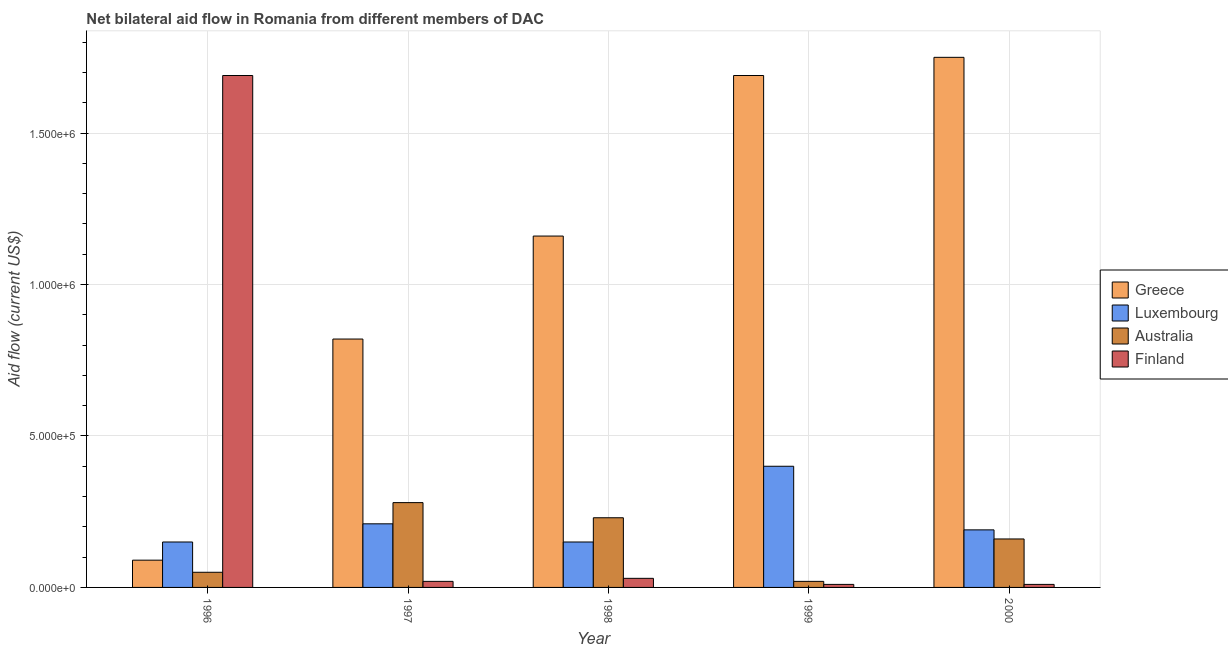How many groups of bars are there?
Give a very brief answer. 5. Are the number of bars per tick equal to the number of legend labels?
Your answer should be compact. Yes. Are the number of bars on each tick of the X-axis equal?
Give a very brief answer. Yes. How many bars are there on the 3rd tick from the left?
Offer a very short reply. 4. What is the amount of aid given by finland in 1997?
Give a very brief answer. 2.00e+04. Across all years, what is the maximum amount of aid given by luxembourg?
Make the answer very short. 4.00e+05. Across all years, what is the minimum amount of aid given by greece?
Keep it short and to the point. 9.00e+04. In which year was the amount of aid given by luxembourg maximum?
Your response must be concise. 1999. What is the total amount of aid given by greece in the graph?
Provide a short and direct response. 5.51e+06. What is the difference between the amount of aid given by luxembourg in 1997 and the amount of aid given by australia in 1996?
Offer a terse response. 6.00e+04. What is the average amount of aid given by australia per year?
Your response must be concise. 1.48e+05. Is the difference between the amount of aid given by australia in 1997 and 2000 greater than the difference between the amount of aid given by greece in 1997 and 2000?
Your answer should be very brief. No. What is the difference between the highest and the second highest amount of aid given by australia?
Your answer should be very brief. 5.00e+04. What is the difference between the highest and the lowest amount of aid given by luxembourg?
Your answer should be compact. 2.50e+05. In how many years, is the amount of aid given by finland greater than the average amount of aid given by finland taken over all years?
Offer a terse response. 1. Is the sum of the amount of aid given by luxembourg in 1998 and 1999 greater than the maximum amount of aid given by australia across all years?
Make the answer very short. Yes. What does the 2nd bar from the left in 1998 represents?
Make the answer very short. Luxembourg. What does the 1st bar from the right in 1999 represents?
Offer a very short reply. Finland. How many bars are there?
Provide a short and direct response. 20. Does the graph contain any zero values?
Offer a terse response. No. Where does the legend appear in the graph?
Give a very brief answer. Center right. How many legend labels are there?
Your answer should be compact. 4. What is the title of the graph?
Keep it short and to the point. Net bilateral aid flow in Romania from different members of DAC. Does "Insurance services" appear as one of the legend labels in the graph?
Provide a short and direct response. No. What is the label or title of the X-axis?
Your answer should be compact. Year. What is the Aid flow (current US$) of Greece in 1996?
Keep it short and to the point. 9.00e+04. What is the Aid flow (current US$) in Luxembourg in 1996?
Your response must be concise. 1.50e+05. What is the Aid flow (current US$) of Australia in 1996?
Ensure brevity in your answer.  5.00e+04. What is the Aid flow (current US$) of Finland in 1996?
Make the answer very short. 1.69e+06. What is the Aid flow (current US$) of Greece in 1997?
Ensure brevity in your answer.  8.20e+05. What is the Aid flow (current US$) of Luxembourg in 1997?
Your answer should be compact. 2.10e+05. What is the Aid flow (current US$) of Greece in 1998?
Offer a terse response. 1.16e+06. What is the Aid flow (current US$) in Luxembourg in 1998?
Offer a very short reply. 1.50e+05. What is the Aid flow (current US$) of Australia in 1998?
Provide a succinct answer. 2.30e+05. What is the Aid flow (current US$) in Greece in 1999?
Make the answer very short. 1.69e+06. What is the Aid flow (current US$) in Luxembourg in 1999?
Make the answer very short. 4.00e+05. What is the Aid flow (current US$) in Australia in 1999?
Keep it short and to the point. 2.00e+04. What is the Aid flow (current US$) in Greece in 2000?
Keep it short and to the point. 1.75e+06. What is the Aid flow (current US$) of Finland in 2000?
Your response must be concise. 10000. Across all years, what is the maximum Aid flow (current US$) of Greece?
Keep it short and to the point. 1.75e+06. Across all years, what is the maximum Aid flow (current US$) of Luxembourg?
Ensure brevity in your answer.  4.00e+05. Across all years, what is the maximum Aid flow (current US$) in Australia?
Make the answer very short. 2.80e+05. Across all years, what is the maximum Aid flow (current US$) in Finland?
Keep it short and to the point. 1.69e+06. Across all years, what is the minimum Aid flow (current US$) in Luxembourg?
Your answer should be compact. 1.50e+05. What is the total Aid flow (current US$) of Greece in the graph?
Provide a short and direct response. 5.51e+06. What is the total Aid flow (current US$) of Luxembourg in the graph?
Keep it short and to the point. 1.10e+06. What is the total Aid flow (current US$) of Australia in the graph?
Ensure brevity in your answer.  7.40e+05. What is the total Aid flow (current US$) of Finland in the graph?
Keep it short and to the point. 1.76e+06. What is the difference between the Aid flow (current US$) of Greece in 1996 and that in 1997?
Offer a terse response. -7.30e+05. What is the difference between the Aid flow (current US$) in Finland in 1996 and that in 1997?
Keep it short and to the point. 1.67e+06. What is the difference between the Aid flow (current US$) in Greece in 1996 and that in 1998?
Make the answer very short. -1.07e+06. What is the difference between the Aid flow (current US$) in Luxembourg in 1996 and that in 1998?
Your answer should be compact. 0. What is the difference between the Aid flow (current US$) in Australia in 1996 and that in 1998?
Provide a succinct answer. -1.80e+05. What is the difference between the Aid flow (current US$) of Finland in 1996 and that in 1998?
Offer a terse response. 1.66e+06. What is the difference between the Aid flow (current US$) of Greece in 1996 and that in 1999?
Make the answer very short. -1.60e+06. What is the difference between the Aid flow (current US$) of Australia in 1996 and that in 1999?
Provide a succinct answer. 3.00e+04. What is the difference between the Aid flow (current US$) of Finland in 1996 and that in 1999?
Provide a short and direct response. 1.68e+06. What is the difference between the Aid flow (current US$) in Greece in 1996 and that in 2000?
Offer a terse response. -1.66e+06. What is the difference between the Aid flow (current US$) in Luxembourg in 1996 and that in 2000?
Keep it short and to the point. -4.00e+04. What is the difference between the Aid flow (current US$) in Finland in 1996 and that in 2000?
Make the answer very short. 1.68e+06. What is the difference between the Aid flow (current US$) in Australia in 1997 and that in 1998?
Your response must be concise. 5.00e+04. What is the difference between the Aid flow (current US$) of Greece in 1997 and that in 1999?
Keep it short and to the point. -8.70e+05. What is the difference between the Aid flow (current US$) of Australia in 1997 and that in 1999?
Provide a short and direct response. 2.60e+05. What is the difference between the Aid flow (current US$) in Greece in 1997 and that in 2000?
Your answer should be compact. -9.30e+05. What is the difference between the Aid flow (current US$) of Luxembourg in 1997 and that in 2000?
Provide a short and direct response. 2.00e+04. What is the difference between the Aid flow (current US$) of Finland in 1997 and that in 2000?
Provide a succinct answer. 10000. What is the difference between the Aid flow (current US$) in Greece in 1998 and that in 1999?
Offer a terse response. -5.30e+05. What is the difference between the Aid flow (current US$) in Greece in 1998 and that in 2000?
Offer a terse response. -5.90e+05. What is the difference between the Aid flow (current US$) of Australia in 1998 and that in 2000?
Offer a terse response. 7.00e+04. What is the difference between the Aid flow (current US$) in Finland in 1998 and that in 2000?
Your answer should be very brief. 2.00e+04. What is the difference between the Aid flow (current US$) of Greece in 1999 and that in 2000?
Offer a terse response. -6.00e+04. What is the difference between the Aid flow (current US$) of Australia in 1996 and the Aid flow (current US$) of Finland in 1997?
Make the answer very short. 3.00e+04. What is the difference between the Aid flow (current US$) in Greece in 1996 and the Aid flow (current US$) in Australia in 1998?
Your answer should be very brief. -1.40e+05. What is the difference between the Aid flow (current US$) of Greece in 1996 and the Aid flow (current US$) of Finland in 1998?
Ensure brevity in your answer.  6.00e+04. What is the difference between the Aid flow (current US$) of Luxembourg in 1996 and the Aid flow (current US$) of Australia in 1998?
Offer a very short reply. -8.00e+04. What is the difference between the Aid flow (current US$) of Greece in 1996 and the Aid flow (current US$) of Luxembourg in 1999?
Ensure brevity in your answer.  -3.10e+05. What is the difference between the Aid flow (current US$) in Greece in 1996 and the Aid flow (current US$) in Australia in 1999?
Your answer should be very brief. 7.00e+04. What is the difference between the Aid flow (current US$) of Greece in 1996 and the Aid flow (current US$) of Finland in 1999?
Your answer should be compact. 8.00e+04. What is the difference between the Aid flow (current US$) of Australia in 1996 and the Aid flow (current US$) of Finland in 1999?
Provide a succinct answer. 4.00e+04. What is the difference between the Aid flow (current US$) in Greece in 1996 and the Aid flow (current US$) in Australia in 2000?
Provide a short and direct response. -7.00e+04. What is the difference between the Aid flow (current US$) in Greece in 1997 and the Aid flow (current US$) in Luxembourg in 1998?
Make the answer very short. 6.70e+05. What is the difference between the Aid flow (current US$) in Greece in 1997 and the Aid flow (current US$) in Australia in 1998?
Your answer should be very brief. 5.90e+05. What is the difference between the Aid flow (current US$) in Greece in 1997 and the Aid flow (current US$) in Finland in 1998?
Keep it short and to the point. 7.90e+05. What is the difference between the Aid flow (current US$) in Luxembourg in 1997 and the Aid flow (current US$) in Finland in 1998?
Make the answer very short. 1.80e+05. What is the difference between the Aid flow (current US$) in Australia in 1997 and the Aid flow (current US$) in Finland in 1998?
Keep it short and to the point. 2.50e+05. What is the difference between the Aid flow (current US$) in Greece in 1997 and the Aid flow (current US$) in Luxembourg in 1999?
Offer a terse response. 4.20e+05. What is the difference between the Aid flow (current US$) of Greece in 1997 and the Aid flow (current US$) of Australia in 1999?
Ensure brevity in your answer.  8.00e+05. What is the difference between the Aid flow (current US$) of Greece in 1997 and the Aid flow (current US$) of Finland in 1999?
Offer a terse response. 8.10e+05. What is the difference between the Aid flow (current US$) of Luxembourg in 1997 and the Aid flow (current US$) of Australia in 1999?
Your answer should be compact. 1.90e+05. What is the difference between the Aid flow (current US$) of Luxembourg in 1997 and the Aid flow (current US$) of Finland in 1999?
Your answer should be compact. 2.00e+05. What is the difference between the Aid flow (current US$) in Australia in 1997 and the Aid flow (current US$) in Finland in 1999?
Ensure brevity in your answer.  2.70e+05. What is the difference between the Aid flow (current US$) in Greece in 1997 and the Aid flow (current US$) in Luxembourg in 2000?
Your response must be concise. 6.30e+05. What is the difference between the Aid flow (current US$) of Greece in 1997 and the Aid flow (current US$) of Australia in 2000?
Make the answer very short. 6.60e+05. What is the difference between the Aid flow (current US$) of Greece in 1997 and the Aid flow (current US$) of Finland in 2000?
Keep it short and to the point. 8.10e+05. What is the difference between the Aid flow (current US$) in Luxembourg in 1997 and the Aid flow (current US$) in Australia in 2000?
Your answer should be compact. 5.00e+04. What is the difference between the Aid flow (current US$) in Australia in 1997 and the Aid flow (current US$) in Finland in 2000?
Offer a terse response. 2.70e+05. What is the difference between the Aid flow (current US$) in Greece in 1998 and the Aid flow (current US$) in Luxembourg in 1999?
Offer a very short reply. 7.60e+05. What is the difference between the Aid flow (current US$) in Greece in 1998 and the Aid flow (current US$) in Australia in 1999?
Ensure brevity in your answer.  1.14e+06. What is the difference between the Aid flow (current US$) in Greece in 1998 and the Aid flow (current US$) in Finland in 1999?
Ensure brevity in your answer.  1.15e+06. What is the difference between the Aid flow (current US$) in Luxembourg in 1998 and the Aid flow (current US$) in Australia in 1999?
Offer a very short reply. 1.30e+05. What is the difference between the Aid flow (current US$) in Greece in 1998 and the Aid flow (current US$) in Luxembourg in 2000?
Offer a very short reply. 9.70e+05. What is the difference between the Aid flow (current US$) in Greece in 1998 and the Aid flow (current US$) in Australia in 2000?
Offer a terse response. 1.00e+06. What is the difference between the Aid flow (current US$) of Greece in 1998 and the Aid flow (current US$) of Finland in 2000?
Provide a succinct answer. 1.15e+06. What is the difference between the Aid flow (current US$) in Luxembourg in 1998 and the Aid flow (current US$) in Australia in 2000?
Give a very brief answer. -10000. What is the difference between the Aid flow (current US$) of Australia in 1998 and the Aid flow (current US$) of Finland in 2000?
Give a very brief answer. 2.20e+05. What is the difference between the Aid flow (current US$) of Greece in 1999 and the Aid flow (current US$) of Luxembourg in 2000?
Ensure brevity in your answer.  1.50e+06. What is the difference between the Aid flow (current US$) of Greece in 1999 and the Aid flow (current US$) of Australia in 2000?
Provide a short and direct response. 1.53e+06. What is the difference between the Aid flow (current US$) in Greece in 1999 and the Aid flow (current US$) in Finland in 2000?
Your answer should be very brief. 1.68e+06. What is the average Aid flow (current US$) of Greece per year?
Offer a terse response. 1.10e+06. What is the average Aid flow (current US$) in Luxembourg per year?
Keep it short and to the point. 2.20e+05. What is the average Aid flow (current US$) in Australia per year?
Ensure brevity in your answer.  1.48e+05. What is the average Aid flow (current US$) of Finland per year?
Give a very brief answer. 3.52e+05. In the year 1996, what is the difference between the Aid flow (current US$) in Greece and Aid flow (current US$) in Luxembourg?
Make the answer very short. -6.00e+04. In the year 1996, what is the difference between the Aid flow (current US$) in Greece and Aid flow (current US$) in Finland?
Provide a succinct answer. -1.60e+06. In the year 1996, what is the difference between the Aid flow (current US$) in Luxembourg and Aid flow (current US$) in Finland?
Ensure brevity in your answer.  -1.54e+06. In the year 1996, what is the difference between the Aid flow (current US$) in Australia and Aid flow (current US$) in Finland?
Ensure brevity in your answer.  -1.64e+06. In the year 1997, what is the difference between the Aid flow (current US$) in Greece and Aid flow (current US$) in Australia?
Offer a very short reply. 5.40e+05. In the year 1997, what is the difference between the Aid flow (current US$) in Luxembourg and Aid flow (current US$) in Finland?
Offer a terse response. 1.90e+05. In the year 1998, what is the difference between the Aid flow (current US$) of Greece and Aid flow (current US$) of Luxembourg?
Your answer should be very brief. 1.01e+06. In the year 1998, what is the difference between the Aid flow (current US$) in Greece and Aid flow (current US$) in Australia?
Your answer should be very brief. 9.30e+05. In the year 1998, what is the difference between the Aid flow (current US$) in Greece and Aid flow (current US$) in Finland?
Give a very brief answer. 1.13e+06. In the year 1998, what is the difference between the Aid flow (current US$) in Luxembourg and Aid flow (current US$) in Australia?
Ensure brevity in your answer.  -8.00e+04. In the year 1998, what is the difference between the Aid flow (current US$) in Luxembourg and Aid flow (current US$) in Finland?
Make the answer very short. 1.20e+05. In the year 1998, what is the difference between the Aid flow (current US$) of Australia and Aid flow (current US$) of Finland?
Offer a terse response. 2.00e+05. In the year 1999, what is the difference between the Aid flow (current US$) in Greece and Aid flow (current US$) in Luxembourg?
Keep it short and to the point. 1.29e+06. In the year 1999, what is the difference between the Aid flow (current US$) of Greece and Aid flow (current US$) of Australia?
Provide a succinct answer. 1.67e+06. In the year 1999, what is the difference between the Aid flow (current US$) of Greece and Aid flow (current US$) of Finland?
Offer a very short reply. 1.68e+06. In the year 1999, what is the difference between the Aid flow (current US$) of Luxembourg and Aid flow (current US$) of Australia?
Ensure brevity in your answer.  3.80e+05. In the year 1999, what is the difference between the Aid flow (current US$) in Australia and Aid flow (current US$) in Finland?
Offer a terse response. 10000. In the year 2000, what is the difference between the Aid flow (current US$) in Greece and Aid flow (current US$) in Luxembourg?
Your response must be concise. 1.56e+06. In the year 2000, what is the difference between the Aid flow (current US$) in Greece and Aid flow (current US$) in Australia?
Give a very brief answer. 1.59e+06. In the year 2000, what is the difference between the Aid flow (current US$) of Greece and Aid flow (current US$) of Finland?
Offer a very short reply. 1.74e+06. What is the ratio of the Aid flow (current US$) in Greece in 1996 to that in 1997?
Give a very brief answer. 0.11. What is the ratio of the Aid flow (current US$) in Luxembourg in 1996 to that in 1997?
Ensure brevity in your answer.  0.71. What is the ratio of the Aid flow (current US$) of Australia in 1996 to that in 1997?
Keep it short and to the point. 0.18. What is the ratio of the Aid flow (current US$) of Finland in 1996 to that in 1997?
Offer a terse response. 84.5. What is the ratio of the Aid flow (current US$) in Greece in 1996 to that in 1998?
Provide a short and direct response. 0.08. What is the ratio of the Aid flow (current US$) of Australia in 1996 to that in 1998?
Ensure brevity in your answer.  0.22. What is the ratio of the Aid flow (current US$) in Finland in 1996 to that in 1998?
Give a very brief answer. 56.33. What is the ratio of the Aid flow (current US$) of Greece in 1996 to that in 1999?
Provide a short and direct response. 0.05. What is the ratio of the Aid flow (current US$) of Australia in 1996 to that in 1999?
Your answer should be very brief. 2.5. What is the ratio of the Aid flow (current US$) in Finland in 1996 to that in 1999?
Ensure brevity in your answer.  169. What is the ratio of the Aid flow (current US$) of Greece in 1996 to that in 2000?
Your answer should be compact. 0.05. What is the ratio of the Aid flow (current US$) in Luxembourg in 1996 to that in 2000?
Your answer should be very brief. 0.79. What is the ratio of the Aid flow (current US$) in Australia in 1996 to that in 2000?
Your answer should be very brief. 0.31. What is the ratio of the Aid flow (current US$) of Finland in 1996 to that in 2000?
Give a very brief answer. 169. What is the ratio of the Aid flow (current US$) in Greece in 1997 to that in 1998?
Your answer should be compact. 0.71. What is the ratio of the Aid flow (current US$) in Luxembourg in 1997 to that in 1998?
Ensure brevity in your answer.  1.4. What is the ratio of the Aid flow (current US$) of Australia in 1997 to that in 1998?
Keep it short and to the point. 1.22. What is the ratio of the Aid flow (current US$) of Greece in 1997 to that in 1999?
Your answer should be very brief. 0.49. What is the ratio of the Aid flow (current US$) in Luxembourg in 1997 to that in 1999?
Offer a very short reply. 0.53. What is the ratio of the Aid flow (current US$) in Finland in 1997 to that in 1999?
Provide a short and direct response. 2. What is the ratio of the Aid flow (current US$) in Greece in 1997 to that in 2000?
Keep it short and to the point. 0.47. What is the ratio of the Aid flow (current US$) of Luxembourg in 1997 to that in 2000?
Your response must be concise. 1.11. What is the ratio of the Aid flow (current US$) of Australia in 1997 to that in 2000?
Ensure brevity in your answer.  1.75. What is the ratio of the Aid flow (current US$) in Greece in 1998 to that in 1999?
Offer a terse response. 0.69. What is the ratio of the Aid flow (current US$) of Luxembourg in 1998 to that in 1999?
Your response must be concise. 0.38. What is the ratio of the Aid flow (current US$) of Finland in 1998 to that in 1999?
Your response must be concise. 3. What is the ratio of the Aid flow (current US$) in Greece in 1998 to that in 2000?
Ensure brevity in your answer.  0.66. What is the ratio of the Aid flow (current US$) of Luxembourg in 1998 to that in 2000?
Provide a short and direct response. 0.79. What is the ratio of the Aid flow (current US$) of Australia in 1998 to that in 2000?
Offer a terse response. 1.44. What is the ratio of the Aid flow (current US$) in Finland in 1998 to that in 2000?
Provide a short and direct response. 3. What is the ratio of the Aid flow (current US$) in Greece in 1999 to that in 2000?
Give a very brief answer. 0.97. What is the ratio of the Aid flow (current US$) in Luxembourg in 1999 to that in 2000?
Offer a terse response. 2.11. What is the ratio of the Aid flow (current US$) of Finland in 1999 to that in 2000?
Provide a short and direct response. 1. What is the difference between the highest and the second highest Aid flow (current US$) in Finland?
Give a very brief answer. 1.66e+06. What is the difference between the highest and the lowest Aid flow (current US$) of Greece?
Give a very brief answer. 1.66e+06. What is the difference between the highest and the lowest Aid flow (current US$) of Finland?
Your answer should be compact. 1.68e+06. 